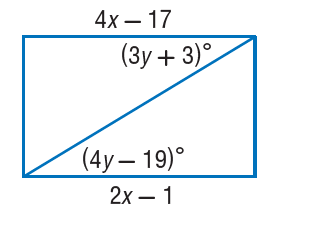Answer the mathemtical geometry problem and directly provide the correct option letter.
Question: Find y so that the quadrilateral is a parallelogram.
Choices: A: 6 B: 20 C: 22 D: 42 C 